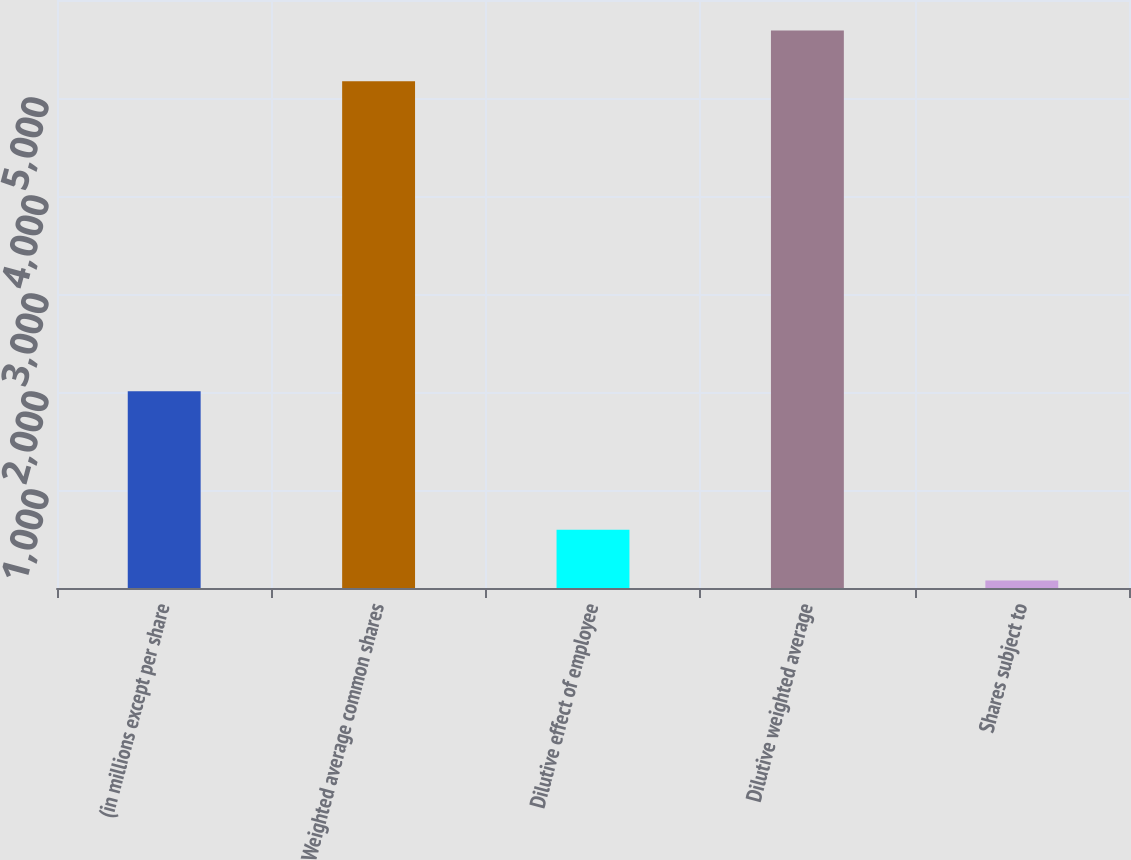Convert chart to OTSL. <chart><loc_0><loc_0><loc_500><loc_500><bar_chart><fcel>(in millions except per share<fcel>Weighted average common shares<fcel>Dilutive effect of employee<fcel>Dilutive weighted average<fcel>Shares subject to<nl><fcel>2007<fcel>5170<fcel>595.3<fcel>5689.3<fcel>76<nl></chart> 